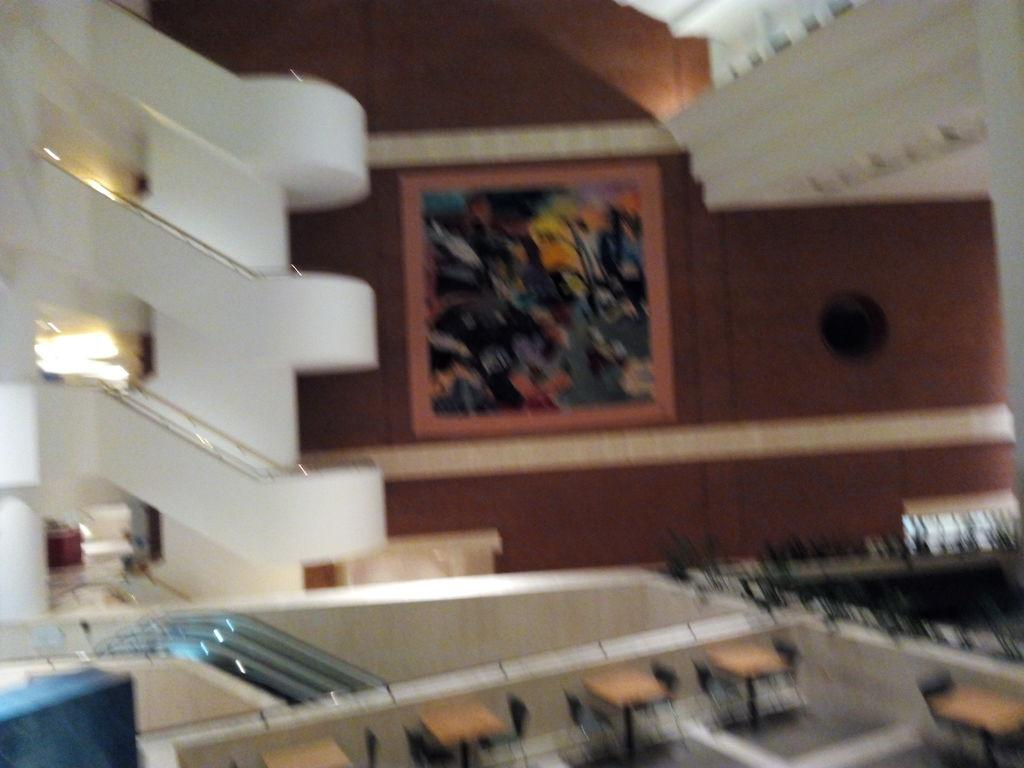What type of architectural feature is present in the image? There is a staircase with railing in the image. What is another feature for moving between floors in the image? There are escalators in the image. What type of furniture is on the floor in the image? There is a group of chairs and tables on the floor in the image. Can you describe any decorative elements in the image? There is a painting on a wall in the image. What type of skate is hanging on the wall in the image? There is no skate present in the image; it features a staircase, escalators, chairs, tables, and a painting. What kind of trouble is the group of chairs causing in the image? There is no indication of any trouble caused by the chairs in the image. 